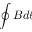Convert formula to latex. <formula><loc_0><loc_0><loc_500><loc_500>\oint B d \ell</formula> 